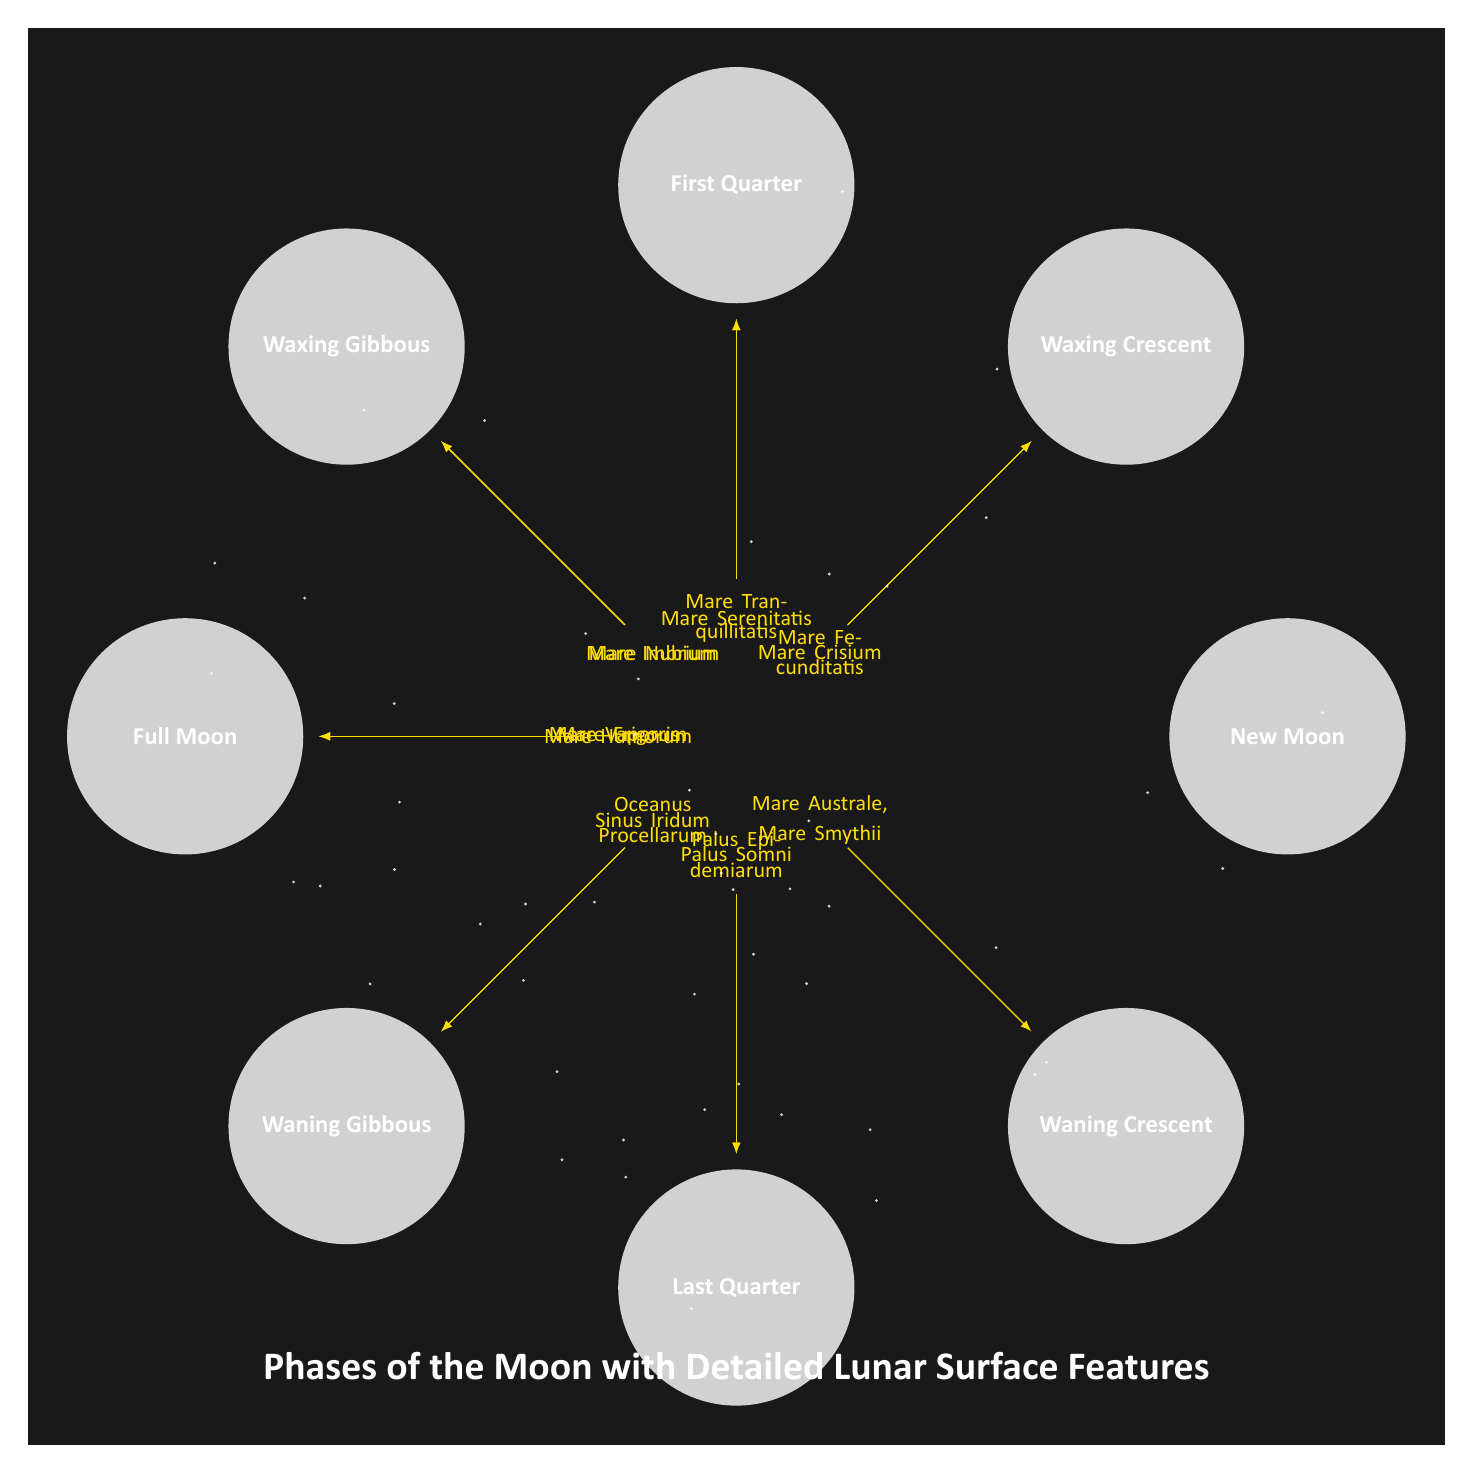What is the phase at 0 degrees? The diagram indicates that at 0 degrees, the Moon phase is labeled as "New Moon".
Answer: New Moon Which lunar feature is associated with the Waxing Crescent phase? The Waxing Crescent phase at 45 degrees has two associated features: Mare Crisium and Mare Fecunditatis.
Answer: Mare Crisium, Mare Fecunditatis How many phases of the Moon are represented in the diagram? The diagram features eight distinct phases of the Moon, each represented by a circle with a corresponding label.
Answer: 8 Which phase has the most lunar surface features listed? The Full Moon phase at 180 degrees includes three lunar features: Mare Frigoris, Mare Vaporum, and Mare Humorum, which is more than any other phase.
Answer: Full Moon What features are associated with the Last Quarter phase? The Last Quarter phase is at 270 degrees and is associated with two features: Palus Somni and Palus Epidemiarum.
Answer: Palus Somni, Palus Epidemiarum Which lunar feature is positioned closest to the Waxing Gibbous phase? The Waxing Gibbous phase at 135 degrees is closest to Mare Imbrium and Mare Nubium, which are located directly above it in the diagram.
Answer: Mare Imbrium, Mare Nubium How does the number of features increase from New Moon to Full Moon? Starting from New Moon with zero features, the feature count increases as follows: Waxing Crescent has 2, First Quarter has 2, Waxing Gibbous has 2, Full Moon has 3, and then the count decreases for the waning phases.
Answer: Increases then decreases What color indicates the lunar features in the diagram? The features are indicated in a shade of yellow that has an orange tint, as specified in the color settings of the diagram.
Answer: Yellow!80!orange 